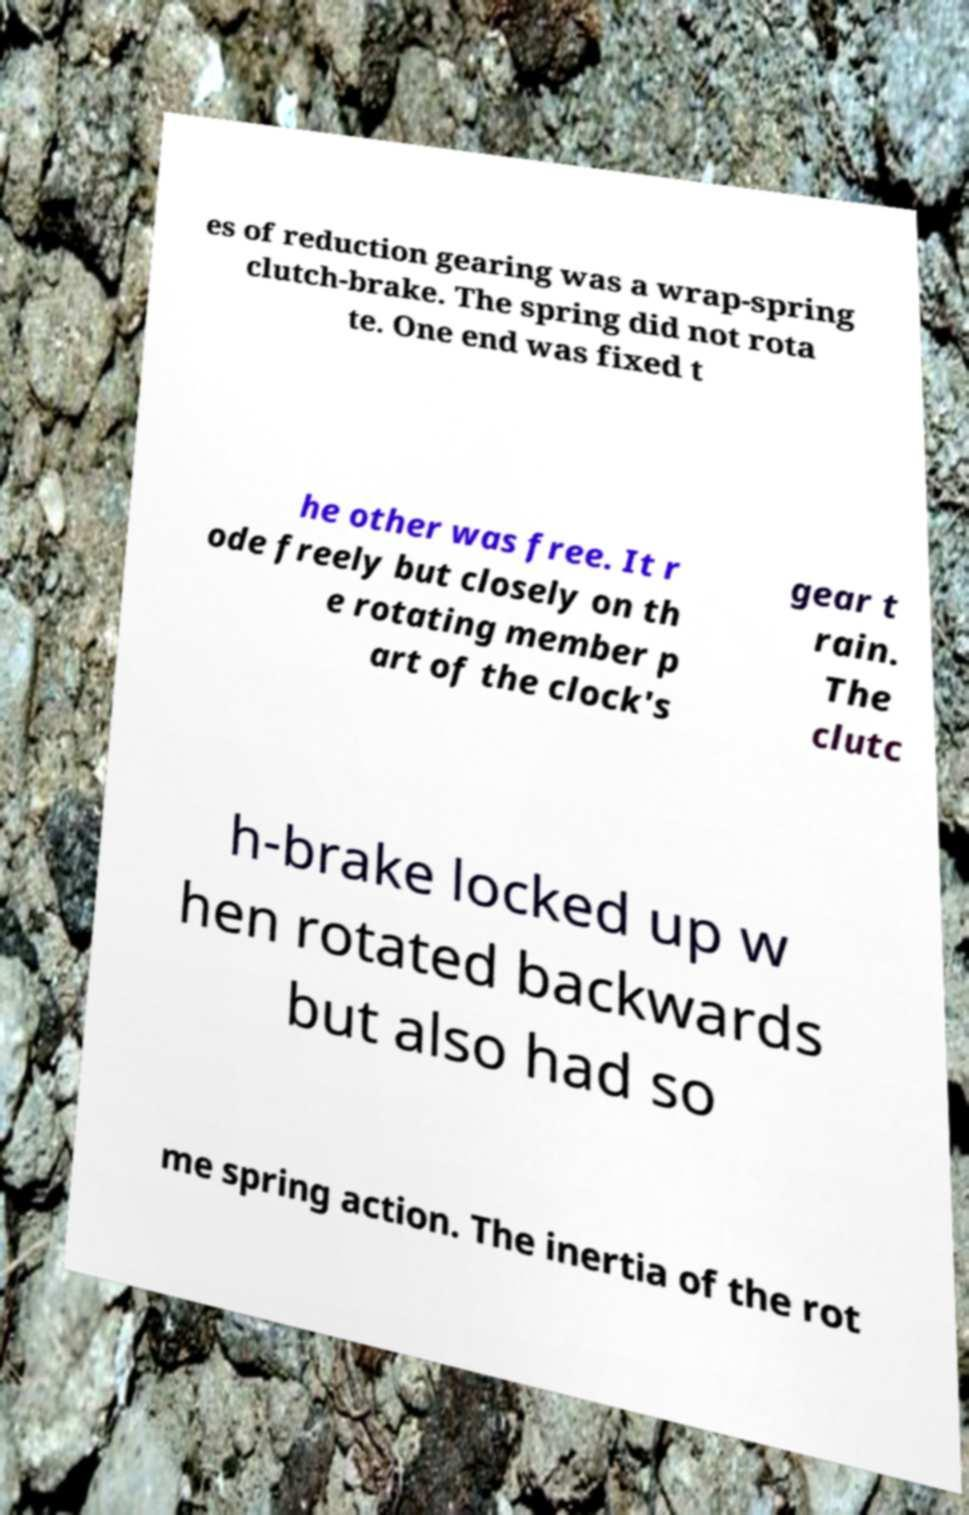What messages or text are displayed in this image? I need them in a readable, typed format. es of reduction gearing was a wrap-spring clutch-brake. The spring did not rota te. One end was fixed t he other was free. It r ode freely but closely on th e rotating member p art of the clock's gear t rain. The clutc h-brake locked up w hen rotated backwards but also had so me spring action. The inertia of the rot 